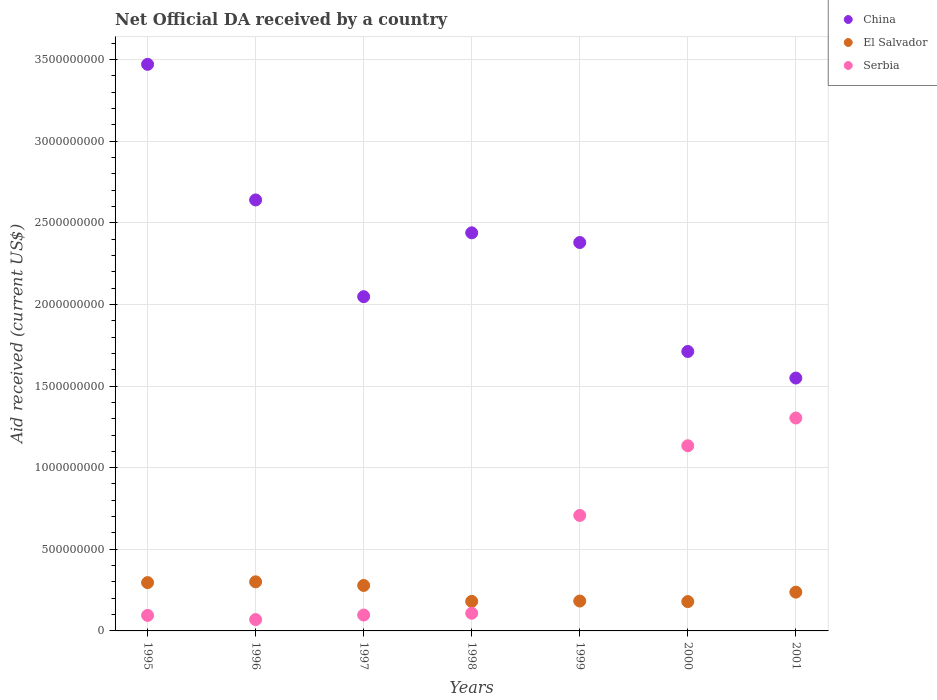How many different coloured dotlines are there?
Provide a succinct answer. 3. Is the number of dotlines equal to the number of legend labels?
Provide a short and direct response. Yes. What is the net official development assistance aid received in Serbia in 1999?
Provide a short and direct response. 7.07e+08. Across all years, what is the maximum net official development assistance aid received in China?
Make the answer very short. 3.47e+09. Across all years, what is the minimum net official development assistance aid received in El Salvador?
Make the answer very short. 1.80e+08. In which year was the net official development assistance aid received in China maximum?
Your response must be concise. 1995. What is the total net official development assistance aid received in China in the graph?
Provide a succinct answer. 1.62e+1. What is the difference between the net official development assistance aid received in China in 1996 and that in 1998?
Make the answer very short. 2.01e+08. What is the difference between the net official development assistance aid received in China in 1998 and the net official development assistance aid received in El Salvador in 1996?
Offer a very short reply. 2.14e+09. What is the average net official development assistance aid received in Serbia per year?
Offer a terse response. 5.02e+08. In the year 2001, what is the difference between the net official development assistance aid received in China and net official development assistance aid received in Serbia?
Offer a terse response. 2.45e+08. In how many years, is the net official development assistance aid received in El Salvador greater than 300000000 US$?
Your response must be concise. 1. What is the ratio of the net official development assistance aid received in El Salvador in 1998 to that in 1999?
Keep it short and to the point. 0.99. Is the net official development assistance aid received in Serbia in 1997 less than that in 1998?
Keep it short and to the point. Yes. What is the difference between the highest and the second highest net official development assistance aid received in Serbia?
Make the answer very short. 1.70e+08. What is the difference between the highest and the lowest net official development assistance aid received in China?
Offer a very short reply. 1.92e+09. In how many years, is the net official development assistance aid received in China greater than the average net official development assistance aid received in China taken over all years?
Ensure brevity in your answer.  4. Does the net official development assistance aid received in El Salvador monotonically increase over the years?
Your answer should be compact. No. Is the net official development assistance aid received in China strictly greater than the net official development assistance aid received in Serbia over the years?
Provide a short and direct response. Yes. What is the difference between two consecutive major ticks on the Y-axis?
Give a very brief answer. 5.00e+08. Does the graph contain grids?
Ensure brevity in your answer.  Yes. How many legend labels are there?
Make the answer very short. 3. How are the legend labels stacked?
Your answer should be very brief. Vertical. What is the title of the graph?
Offer a very short reply. Net Official DA received by a country. Does "Sint Maarten (Dutch part)" appear as one of the legend labels in the graph?
Give a very brief answer. No. What is the label or title of the X-axis?
Provide a succinct answer. Years. What is the label or title of the Y-axis?
Your answer should be compact. Aid received (current US$). What is the Aid received (current US$) of China in 1995?
Offer a very short reply. 3.47e+09. What is the Aid received (current US$) of El Salvador in 1995?
Your answer should be very brief. 2.96e+08. What is the Aid received (current US$) of Serbia in 1995?
Make the answer very short. 9.51e+07. What is the Aid received (current US$) of China in 1996?
Your response must be concise. 2.64e+09. What is the Aid received (current US$) in El Salvador in 1996?
Keep it short and to the point. 3.01e+08. What is the Aid received (current US$) of Serbia in 1996?
Offer a terse response. 6.95e+07. What is the Aid received (current US$) of China in 1997?
Provide a short and direct response. 2.05e+09. What is the Aid received (current US$) of El Salvador in 1997?
Keep it short and to the point. 2.79e+08. What is the Aid received (current US$) of Serbia in 1997?
Offer a very short reply. 9.74e+07. What is the Aid received (current US$) in China in 1998?
Keep it short and to the point. 2.44e+09. What is the Aid received (current US$) of El Salvador in 1998?
Your response must be concise. 1.81e+08. What is the Aid received (current US$) in Serbia in 1998?
Your answer should be very brief. 1.08e+08. What is the Aid received (current US$) of China in 1999?
Make the answer very short. 2.38e+09. What is the Aid received (current US$) in El Salvador in 1999?
Keep it short and to the point. 1.83e+08. What is the Aid received (current US$) in Serbia in 1999?
Make the answer very short. 7.07e+08. What is the Aid received (current US$) in China in 2000?
Your answer should be compact. 1.71e+09. What is the Aid received (current US$) of El Salvador in 2000?
Ensure brevity in your answer.  1.80e+08. What is the Aid received (current US$) in Serbia in 2000?
Ensure brevity in your answer.  1.13e+09. What is the Aid received (current US$) in China in 2001?
Your answer should be very brief. 1.55e+09. What is the Aid received (current US$) in El Salvador in 2001?
Your answer should be very brief. 2.38e+08. What is the Aid received (current US$) in Serbia in 2001?
Offer a terse response. 1.30e+09. Across all years, what is the maximum Aid received (current US$) in China?
Provide a short and direct response. 3.47e+09. Across all years, what is the maximum Aid received (current US$) of El Salvador?
Your answer should be very brief. 3.01e+08. Across all years, what is the maximum Aid received (current US$) in Serbia?
Give a very brief answer. 1.30e+09. Across all years, what is the minimum Aid received (current US$) of China?
Make the answer very short. 1.55e+09. Across all years, what is the minimum Aid received (current US$) of El Salvador?
Offer a very short reply. 1.80e+08. Across all years, what is the minimum Aid received (current US$) in Serbia?
Provide a succinct answer. 6.95e+07. What is the total Aid received (current US$) in China in the graph?
Provide a succinct answer. 1.62e+1. What is the total Aid received (current US$) in El Salvador in the graph?
Your response must be concise. 1.66e+09. What is the total Aid received (current US$) of Serbia in the graph?
Your answer should be very brief. 3.52e+09. What is the difference between the Aid received (current US$) of China in 1995 and that in 1996?
Your answer should be compact. 8.31e+08. What is the difference between the Aid received (current US$) in El Salvador in 1995 and that in 1996?
Offer a terse response. -4.81e+06. What is the difference between the Aid received (current US$) of Serbia in 1995 and that in 1996?
Make the answer very short. 2.56e+07. What is the difference between the Aid received (current US$) in China in 1995 and that in 1997?
Your answer should be compact. 1.42e+09. What is the difference between the Aid received (current US$) of El Salvador in 1995 and that in 1997?
Offer a terse response. 1.74e+07. What is the difference between the Aid received (current US$) of Serbia in 1995 and that in 1997?
Keep it short and to the point. -2.30e+06. What is the difference between the Aid received (current US$) in China in 1995 and that in 1998?
Ensure brevity in your answer.  1.03e+09. What is the difference between the Aid received (current US$) in El Salvador in 1995 and that in 1998?
Offer a terse response. 1.15e+08. What is the difference between the Aid received (current US$) of Serbia in 1995 and that in 1998?
Your response must be concise. -1.32e+07. What is the difference between the Aid received (current US$) in China in 1995 and that in 1999?
Provide a succinct answer. 1.09e+09. What is the difference between the Aid received (current US$) of El Salvador in 1995 and that in 1999?
Offer a terse response. 1.13e+08. What is the difference between the Aid received (current US$) in Serbia in 1995 and that in 1999?
Offer a very short reply. -6.12e+08. What is the difference between the Aid received (current US$) of China in 1995 and that in 2000?
Your answer should be very brief. 1.76e+09. What is the difference between the Aid received (current US$) in El Salvador in 1995 and that in 2000?
Give a very brief answer. 1.16e+08. What is the difference between the Aid received (current US$) in Serbia in 1995 and that in 2000?
Offer a very short reply. -1.04e+09. What is the difference between the Aid received (current US$) of China in 1995 and that in 2001?
Make the answer very short. 1.92e+09. What is the difference between the Aid received (current US$) of El Salvador in 1995 and that in 2001?
Give a very brief answer. 5.84e+07. What is the difference between the Aid received (current US$) of Serbia in 1995 and that in 2001?
Your response must be concise. -1.21e+09. What is the difference between the Aid received (current US$) in China in 1996 and that in 1997?
Your answer should be very brief. 5.93e+08. What is the difference between the Aid received (current US$) in El Salvador in 1996 and that in 1997?
Make the answer very short. 2.22e+07. What is the difference between the Aid received (current US$) in Serbia in 1996 and that in 1997?
Your response must be concise. -2.78e+07. What is the difference between the Aid received (current US$) in China in 1996 and that in 1998?
Offer a terse response. 2.01e+08. What is the difference between the Aid received (current US$) of El Salvador in 1996 and that in 1998?
Offer a very short reply. 1.20e+08. What is the difference between the Aid received (current US$) in Serbia in 1996 and that in 1998?
Keep it short and to the point. -3.87e+07. What is the difference between the Aid received (current US$) in China in 1996 and that in 1999?
Offer a very short reply. 2.61e+08. What is the difference between the Aid received (current US$) of El Salvador in 1996 and that in 1999?
Offer a terse response. 1.18e+08. What is the difference between the Aid received (current US$) in Serbia in 1996 and that in 1999?
Offer a very short reply. -6.38e+08. What is the difference between the Aid received (current US$) of China in 1996 and that in 2000?
Offer a terse response. 9.28e+08. What is the difference between the Aid received (current US$) of El Salvador in 1996 and that in 2000?
Provide a short and direct response. 1.21e+08. What is the difference between the Aid received (current US$) in Serbia in 1996 and that in 2000?
Ensure brevity in your answer.  -1.06e+09. What is the difference between the Aid received (current US$) of China in 1996 and that in 2001?
Provide a succinct answer. 1.09e+09. What is the difference between the Aid received (current US$) of El Salvador in 1996 and that in 2001?
Provide a short and direct response. 6.32e+07. What is the difference between the Aid received (current US$) in Serbia in 1996 and that in 2001?
Give a very brief answer. -1.23e+09. What is the difference between the Aid received (current US$) of China in 1997 and that in 1998?
Your response must be concise. -3.91e+08. What is the difference between the Aid received (current US$) in El Salvador in 1997 and that in 1998?
Your answer should be very brief. 9.76e+07. What is the difference between the Aid received (current US$) in Serbia in 1997 and that in 1998?
Keep it short and to the point. -1.09e+07. What is the difference between the Aid received (current US$) of China in 1997 and that in 1999?
Offer a very short reply. -3.32e+08. What is the difference between the Aid received (current US$) of El Salvador in 1997 and that in 1999?
Your answer should be compact. 9.54e+07. What is the difference between the Aid received (current US$) of Serbia in 1997 and that in 1999?
Offer a terse response. -6.10e+08. What is the difference between the Aid received (current US$) in China in 1997 and that in 2000?
Provide a succinct answer. 3.36e+08. What is the difference between the Aid received (current US$) in El Salvador in 1997 and that in 2000?
Keep it short and to the point. 9.89e+07. What is the difference between the Aid received (current US$) in Serbia in 1997 and that in 2000?
Your answer should be very brief. -1.04e+09. What is the difference between the Aid received (current US$) of China in 1997 and that in 2001?
Offer a very short reply. 4.98e+08. What is the difference between the Aid received (current US$) of El Salvador in 1997 and that in 2001?
Keep it short and to the point. 4.10e+07. What is the difference between the Aid received (current US$) in Serbia in 1997 and that in 2001?
Give a very brief answer. -1.21e+09. What is the difference between the Aid received (current US$) of China in 1998 and that in 1999?
Provide a succinct answer. 5.93e+07. What is the difference between the Aid received (current US$) of El Salvador in 1998 and that in 1999?
Provide a short and direct response. -2.15e+06. What is the difference between the Aid received (current US$) in Serbia in 1998 and that in 1999?
Give a very brief answer. -5.99e+08. What is the difference between the Aid received (current US$) of China in 1998 and that in 2000?
Your answer should be very brief. 7.27e+08. What is the difference between the Aid received (current US$) in El Salvador in 1998 and that in 2000?
Offer a very short reply. 1.28e+06. What is the difference between the Aid received (current US$) in Serbia in 1998 and that in 2000?
Provide a succinct answer. -1.03e+09. What is the difference between the Aid received (current US$) in China in 1998 and that in 2001?
Provide a short and direct response. 8.90e+08. What is the difference between the Aid received (current US$) in El Salvador in 1998 and that in 2001?
Ensure brevity in your answer.  -5.66e+07. What is the difference between the Aid received (current US$) in Serbia in 1998 and that in 2001?
Provide a short and direct response. -1.20e+09. What is the difference between the Aid received (current US$) in China in 1999 and that in 2000?
Give a very brief answer. 6.68e+08. What is the difference between the Aid received (current US$) in El Salvador in 1999 and that in 2000?
Keep it short and to the point. 3.43e+06. What is the difference between the Aid received (current US$) in Serbia in 1999 and that in 2000?
Make the answer very short. -4.27e+08. What is the difference between the Aid received (current US$) of China in 1999 and that in 2001?
Keep it short and to the point. 8.30e+08. What is the difference between the Aid received (current US$) of El Salvador in 1999 and that in 2001?
Give a very brief answer. -5.44e+07. What is the difference between the Aid received (current US$) in Serbia in 1999 and that in 2001?
Your response must be concise. -5.97e+08. What is the difference between the Aid received (current US$) of China in 2000 and that in 2001?
Make the answer very short. 1.63e+08. What is the difference between the Aid received (current US$) of El Salvador in 2000 and that in 2001?
Your response must be concise. -5.79e+07. What is the difference between the Aid received (current US$) of Serbia in 2000 and that in 2001?
Keep it short and to the point. -1.70e+08. What is the difference between the Aid received (current US$) of China in 1995 and the Aid received (current US$) of El Salvador in 1996?
Offer a very short reply. 3.17e+09. What is the difference between the Aid received (current US$) in China in 1995 and the Aid received (current US$) in Serbia in 1996?
Keep it short and to the point. 3.40e+09. What is the difference between the Aid received (current US$) in El Salvador in 1995 and the Aid received (current US$) in Serbia in 1996?
Your answer should be compact. 2.26e+08. What is the difference between the Aid received (current US$) of China in 1995 and the Aid received (current US$) of El Salvador in 1997?
Ensure brevity in your answer.  3.19e+09. What is the difference between the Aid received (current US$) in China in 1995 and the Aid received (current US$) in Serbia in 1997?
Your answer should be compact. 3.37e+09. What is the difference between the Aid received (current US$) of El Salvador in 1995 and the Aid received (current US$) of Serbia in 1997?
Your answer should be very brief. 1.99e+08. What is the difference between the Aid received (current US$) in China in 1995 and the Aid received (current US$) in El Salvador in 1998?
Your answer should be very brief. 3.29e+09. What is the difference between the Aid received (current US$) in China in 1995 and the Aid received (current US$) in Serbia in 1998?
Your response must be concise. 3.36e+09. What is the difference between the Aid received (current US$) of El Salvador in 1995 and the Aid received (current US$) of Serbia in 1998?
Give a very brief answer. 1.88e+08. What is the difference between the Aid received (current US$) in China in 1995 and the Aid received (current US$) in El Salvador in 1999?
Your answer should be compact. 3.29e+09. What is the difference between the Aid received (current US$) in China in 1995 and the Aid received (current US$) in Serbia in 1999?
Make the answer very short. 2.76e+09. What is the difference between the Aid received (current US$) in El Salvador in 1995 and the Aid received (current US$) in Serbia in 1999?
Your answer should be compact. -4.11e+08. What is the difference between the Aid received (current US$) in China in 1995 and the Aid received (current US$) in El Salvador in 2000?
Provide a short and direct response. 3.29e+09. What is the difference between the Aid received (current US$) of China in 1995 and the Aid received (current US$) of Serbia in 2000?
Make the answer very short. 2.34e+09. What is the difference between the Aid received (current US$) of El Salvador in 1995 and the Aid received (current US$) of Serbia in 2000?
Your response must be concise. -8.38e+08. What is the difference between the Aid received (current US$) of China in 1995 and the Aid received (current US$) of El Salvador in 2001?
Provide a short and direct response. 3.23e+09. What is the difference between the Aid received (current US$) in China in 1995 and the Aid received (current US$) in Serbia in 2001?
Give a very brief answer. 2.17e+09. What is the difference between the Aid received (current US$) of El Salvador in 1995 and the Aid received (current US$) of Serbia in 2001?
Ensure brevity in your answer.  -1.01e+09. What is the difference between the Aid received (current US$) of China in 1996 and the Aid received (current US$) of El Salvador in 1997?
Ensure brevity in your answer.  2.36e+09. What is the difference between the Aid received (current US$) in China in 1996 and the Aid received (current US$) in Serbia in 1997?
Make the answer very short. 2.54e+09. What is the difference between the Aid received (current US$) of El Salvador in 1996 and the Aid received (current US$) of Serbia in 1997?
Your response must be concise. 2.03e+08. What is the difference between the Aid received (current US$) in China in 1996 and the Aid received (current US$) in El Salvador in 1998?
Your response must be concise. 2.46e+09. What is the difference between the Aid received (current US$) in China in 1996 and the Aid received (current US$) in Serbia in 1998?
Keep it short and to the point. 2.53e+09. What is the difference between the Aid received (current US$) in El Salvador in 1996 and the Aid received (current US$) in Serbia in 1998?
Provide a short and direct response. 1.93e+08. What is the difference between the Aid received (current US$) of China in 1996 and the Aid received (current US$) of El Salvador in 1999?
Make the answer very short. 2.46e+09. What is the difference between the Aid received (current US$) of China in 1996 and the Aid received (current US$) of Serbia in 1999?
Provide a short and direct response. 1.93e+09. What is the difference between the Aid received (current US$) in El Salvador in 1996 and the Aid received (current US$) in Serbia in 1999?
Offer a terse response. -4.07e+08. What is the difference between the Aid received (current US$) in China in 1996 and the Aid received (current US$) in El Salvador in 2000?
Your answer should be very brief. 2.46e+09. What is the difference between the Aid received (current US$) in China in 1996 and the Aid received (current US$) in Serbia in 2000?
Offer a very short reply. 1.51e+09. What is the difference between the Aid received (current US$) in El Salvador in 1996 and the Aid received (current US$) in Serbia in 2000?
Provide a succinct answer. -8.34e+08. What is the difference between the Aid received (current US$) in China in 1996 and the Aid received (current US$) in El Salvador in 2001?
Your response must be concise. 2.40e+09. What is the difference between the Aid received (current US$) in China in 1996 and the Aid received (current US$) in Serbia in 2001?
Provide a succinct answer. 1.34e+09. What is the difference between the Aid received (current US$) in El Salvador in 1996 and the Aid received (current US$) in Serbia in 2001?
Provide a succinct answer. -1.00e+09. What is the difference between the Aid received (current US$) of China in 1997 and the Aid received (current US$) of El Salvador in 1998?
Provide a short and direct response. 1.87e+09. What is the difference between the Aid received (current US$) of China in 1997 and the Aid received (current US$) of Serbia in 1998?
Offer a very short reply. 1.94e+09. What is the difference between the Aid received (current US$) in El Salvador in 1997 and the Aid received (current US$) in Serbia in 1998?
Offer a terse response. 1.70e+08. What is the difference between the Aid received (current US$) of China in 1997 and the Aid received (current US$) of El Salvador in 1999?
Make the answer very short. 1.86e+09. What is the difference between the Aid received (current US$) of China in 1997 and the Aid received (current US$) of Serbia in 1999?
Provide a short and direct response. 1.34e+09. What is the difference between the Aid received (current US$) of El Salvador in 1997 and the Aid received (current US$) of Serbia in 1999?
Provide a short and direct response. -4.29e+08. What is the difference between the Aid received (current US$) of China in 1997 and the Aid received (current US$) of El Salvador in 2000?
Provide a succinct answer. 1.87e+09. What is the difference between the Aid received (current US$) in China in 1997 and the Aid received (current US$) in Serbia in 2000?
Provide a succinct answer. 9.13e+08. What is the difference between the Aid received (current US$) of El Salvador in 1997 and the Aid received (current US$) of Serbia in 2000?
Your response must be concise. -8.56e+08. What is the difference between the Aid received (current US$) in China in 1997 and the Aid received (current US$) in El Salvador in 2001?
Give a very brief answer. 1.81e+09. What is the difference between the Aid received (current US$) in China in 1997 and the Aid received (current US$) in Serbia in 2001?
Make the answer very short. 7.43e+08. What is the difference between the Aid received (current US$) in El Salvador in 1997 and the Aid received (current US$) in Serbia in 2001?
Offer a terse response. -1.03e+09. What is the difference between the Aid received (current US$) in China in 1998 and the Aid received (current US$) in El Salvador in 1999?
Provide a succinct answer. 2.26e+09. What is the difference between the Aid received (current US$) in China in 1998 and the Aid received (current US$) in Serbia in 1999?
Your response must be concise. 1.73e+09. What is the difference between the Aid received (current US$) of El Salvador in 1998 and the Aid received (current US$) of Serbia in 1999?
Provide a short and direct response. -5.26e+08. What is the difference between the Aid received (current US$) in China in 1998 and the Aid received (current US$) in El Salvador in 2000?
Your answer should be compact. 2.26e+09. What is the difference between the Aid received (current US$) of China in 1998 and the Aid received (current US$) of Serbia in 2000?
Ensure brevity in your answer.  1.30e+09. What is the difference between the Aid received (current US$) of El Salvador in 1998 and the Aid received (current US$) of Serbia in 2000?
Your answer should be very brief. -9.53e+08. What is the difference between the Aid received (current US$) in China in 1998 and the Aid received (current US$) in El Salvador in 2001?
Your answer should be very brief. 2.20e+09. What is the difference between the Aid received (current US$) in China in 1998 and the Aid received (current US$) in Serbia in 2001?
Offer a terse response. 1.13e+09. What is the difference between the Aid received (current US$) in El Salvador in 1998 and the Aid received (current US$) in Serbia in 2001?
Ensure brevity in your answer.  -1.12e+09. What is the difference between the Aid received (current US$) of China in 1999 and the Aid received (current US$) of El Salvador in 2000?
Ensure brevity in your answer.  2.20e+09. What is the difference between the Aid received (current US$) of China in 1999 and the Aid received (current US$) of Serbia in 2000?
Your answer should be compact. 1.24e+09. What is the difference between the Aid received (current US$) of El Salvador in 1999 and the Aid received (current US$) of Serbia in 2000?
Provide a short and direct response. -9.51e+08. What is the difference between the Aid received (current US$) of China in 1999 and the Aid received (current US$) of El Salvador in 2001?
Give a very brief answer. 2.14e+09. What is the difference between the Aid received (current US$) in China in 1999 and the Aid received (current US$) in Serbia in 2001?
Offer a very short reply. 1.08e+09. What is the difference between the Aid received (current US$) in El Salvador in 1999 and the Aid received (current US$) in Serbia in 2001?
Keep it short and to the point. -1.12e+09. What is the difference between the Aid received (current US$) of China in 2000 and the Aid received (current US$) of El Salvador in 2001?
Your response must be concise. 1.47e+09. What is the difference between the Aid received (current US$) of China in 2000 and the Aid received (current US$) of Serbia in 2001?
Your answer should be very brief. 4.08e+08. What is the difference between the Aid received (current US$) of El Salvador in 2000 and the Aid received (current US$) of Serbia in 2001?
Give a very brief answer. -1.12e+09. What is the average Aid received (current US$) in China per year?
Your answer should be compact. 2.32e+09. What is the average Aid received (current US$) in El Salvador per year?
Give a very brief answer. 2.37e+08. What is the average Aid received (current US$) in Serbia per year?
Provide a succinct answer. 5.02e+08. In the year 1995, what is the difference between the Aid received (current US$) in China and Aid received (current US$) in El Salvador?
Provide a short and direct response. 3.17e+09. In the year 1995, what is the difference between the Aid received (current US$) in China and Aid received (current US$) in Serbia?
Ensure brevity in your answer.  3.38e+09. In the year 1995, what is the difference between the Aid received (current US$) of El Salvador and Aid received (current US$) of Serbia?
Make the answer very short. 2.01e+08. In the year 1996, what is the difference between the Aid received (current US$) of China and Aid received (current US$) of El Salvador?
Ensure brevity in your answer.  2.34e+09. In the year 1996, what is the difference between the Aid received (current US$) in China and Aid received (current US$) in Serbia?
Offer a terse response. 2.57e+09. In the year 1996, what is the difference between the Aid received (current US$) of El Salvador and Aid received (current US$) of Serbia?
Give a very brief answer. 2.31e+08. In the year 1997, what is the difference between the Aid received (current US$) in China and Aid received (current US$) in El Salvador?
Provide a short and direct response. 1.77e+09. In the year 1997, what is the difference between the Aid received (current US$) in China and Aid received (current US$) in Serbia?
Offer a terse response. 1.95e+09. In the year 1997, what is the difference between the Aid received (current US$) of El Salvador and Aid received (current US$) of Serbia?
Ensure brevity in your answer.  1.81e+08. In the year 1998, what is the difference between the Aid received (current US$) of China and Aid received (current US$) of El Salvador?
Ensure brevity in your answer.  2.26e+09. In the year 1998, what is the difference between the Aid received (current US$) of China and Aid received (current US$) of Serbia?
Give a very brief answer. 2.33e+09. In the year 1998, what is the difference between the Aid received (current US$) in El Salvador and Aid received (current US$) in Serbia?
Offer a terse response. 7.27e+07. In the year 1999, what is the difference between the Aid received (current US$) of China and Aid received (current US$) of El Salvador?
Offer a terse response. 2.20e+09. In the year 1999, what is the difference between the Aid received (current US$) of China and Aid received (current US$) of Serbia?
Your answer should be very brief. 1.67e+09. In the year 1999, what is the difference between the Aid received (current US$) in El Salvador and Aid received (current US$) in Serbia?
Your answer should be compact. -5.24e+08. In the year 2000, what is the difference between the Aid received (current US$) of China and Aid received (current US$) of El Salvador?
Your answer should be very brief. 1.53e+09. In the year 2000, what is the difference between the Aid received (current US$) of China and Aid received (current US$) of Serbia?
Offer a very short reply. 5.77e+08. In the year 2000, what is the difference between the Aid received (current US$) in El Salvador and Aid received (current US$) in Serbia?
Provide a succinct answer. -9.55e+08. In the year 2001, what is the difference between the Aid received (current US$) of China and Aid received (current US$) of El Salvador?
Your response must be concise. 1.31e+09. In the year 2001, what is the difference between the Aid received (current US$) of China and Aid received (current US$) of Serbia?
Offer a terse response. 2.45e+08. In the year 2001, what is the difference between the Aid received (current US$) of El Salvador and Aid received (current US$) of Serbia?
Your answer should be compact. -1.07e+09. What is the ratio of the Aid received (current US$) in China in 1995 to that in 1996?
Your response must be concise. 1.31. What is the ratio of the Aid received (current US$) of El Salvador in 1995 to that in 1996?
Your answer should be compact. 0.98. What is the ratio of the Aid received (current US$) of Serbia in 1995 to that in 1996?
Your answer should be very brief. 1.37. What is the ratio of the Aid received (current US$) of China in 1995 to that in 1997?
Ensure brevity in your answer.  1.7. What is the ratio of the Aid received (current US$) in El Salvador in 1995 to that in 1997?
Provide a succinct answer. 1.06. What is the ratio of the Aid received (current US$) in Serbia in 1995 to that in 1997?
Ensure brevity in your answer.  0.98. What is the ratio of the Aid received (current US$) of China in 1995 to that in 1998?
Offer a very short reply. 1.42. What is the ratio of the Aid received (current US$) in El Salvador in 1995 to that in 1998?
Give a very brief answer. 1.64. What is the ratio of the Aid received (current US$) of Serbia in 1995 to that in 1998?
Give a very brief answer. 0.88. What is the ratio of the Aid received (current US$) of China in 1995 to that in 1999?
Your response must be concise. 1.46. What is the ratio of the Aid received (current US$) in El Salvador in 1995 to that in 1999?
Ensure brevity in your answer.  1.62. What is the ratio of the Aid received (current US$) in Serbia in 1995 to that in 1999?
Your answer should be very brief. 0.13. What is the ratio of the Aid received (current US$) in China in 1995 to that in 2000?
Your answer should be compact. 2.03. What is the ratio of the Aid received (current US$) in El Salvador in 1995 to that in 2000?
Give a very brief answer. 1.65. What is the ratio of the Aid received (current US$) of Serbia in 1995 to that in 2000?
Ensure brevity in your answer.  0.08. What is the ratio of the Aid received (current US$) in China in 1995 to that in 2001?
Your answer should be very brief. 2.24. What is the ratio of the Aid received (current US$) of El Salvador in 1995 to that in 2001?
Keep it short and to the point. 1.25. What is the ratio of the Aid received (current US$) in Serbia in 1995 to that in 2001?
Make the answer very short. 0.07. What is the ratio of the Aid received (current US$) of China in 1996 to that in 1997?
Ensure brevity in your answer.  1.29. What is the ratio of the Aid received (current US$) of El Salvador in 1996 to that in 1997?
Your answer should be very brief. 1.08. What is the ratio of the Aid received (current US$) in Serbia in 1996 to that in 1997?
Offer a terse response. 0.71. What is the ratio of the Aid received (current US$) of China in 1996 to that in 1998?
Offer a very short reply. 1.08. What is the ratio of the Aid received (current US$) in El Salvador in 1996 to that in 1998?
Offer a terse response. 1.66. What is the ratio of the Aid received (current US$) of Serbia in 1996 to that in 1998?
Make the answer very short. 0.64. What is the ratio of the Aid received (current US$) of China in 1996 to that in 1999?
Offer a terse response. 1.11. What is the ratio of the Aid received (current US$) of El Salvador in 1996 to that in 1999?
Offer a terse response. 1.64. What is the ratio of the Aid received (current US$) of Serbia in 1996 to that in 1999?
Your answer should be compact. 0.1. What is the ratio of the Aid received (current US$) in China in 1996 to that in 2000?
Your answer should be compact. 1.54. What is the ratio of the Aid received (current US$) of El Salvador in 1996 to that in 2000?
Make the answer very short. 1.67. What is the ratio of the Aid received (current US$) in Serbia in 1996 to that in 2000?
Keep it short and to the point. 0.06. What is the ratio of the Aid received (current US$) in China in 1996 to that in 2001?
Your response must be concise. 1.7. What is the ratio of the Aid received (current US$) of El Salvador in 1996 to that in 2001?
Give a very brief answer. 1.27. What is the ratio of the Aid received (current US$) in Serbia in 1996 to that in 2001?
Ensure brevity in your answer.  0.05. What is the ratio of the Aid received (current US$) of China in 1997 to that in 1998?
Keep it short and to the point. 0.84. What is the ratio of the Aid received (current US$) in El Salvador in 1997 to that in 1998?
Offer a terse response. 1.54. What is the ratio of the Aid received (current US$) in Serbia in 1997 to that in 1998?
Ensure brevity in your answer.  0.9. What is the ratio of the Aid received (current US$) of China in 1997 to that in 1999?
Give a very brief answer. 0.86. What is the ratio of the Aid received (current US$) in El Salvador in 1997 to that in 1999?
Keep it short and to the point. 1.52. What is the ratio of the Aid received (current US$) in Serbia in 1997 to that in 1999?
Make the answer very short. 0.14. What is the ratio of the Aid received (current US$) of China in 1997 to that in 2000?
Make the answer very short. 1.2. What is the ratio of the Aid received (current US$) in El Salvador in 1997 to that in 2000?
Give a very brief answer. 1.55. What is the ratio of the Aid received (current US$) of Serbia in 1997 to that in 2000?
Make the answer very short. 0.09. What is the ratio of the Aid received (current US$) in China in 1997 to that in 2001?
Your answer should be compact. 1.32. What is the ratio of the Aid received (current US$) of El Salvador in 1997 to that in 2001?
Provide a succinct answer. 1.17. What is the ratio of the Aid received (current US$) of Serbia in 1997 to that in 2001?
Ensure brevity in your answer.  0.07. What is the ratio of the Aid received (current US$) in China in 1998 to that in 1999?
Offer a very short reply. 1.02. What is the ratio of the Aid received (current US$) in El Salvador in 1998 to that in 1999?
Give a very brief answer. 0.99. What is the ratio of the Aid received (current US$) in Serbia in 1998 to that in 1999?
Offer a very short reply. 0.15. What is the ratio of the Aid received (current US$) in China in 1998 to that in 2000?
Your answer should be very brief. 1.42. What is the ratio of the Aid received (current US$) in El Salvador in 1998 to that in 2000?
Offer a very short reply. 1.01. What is the ratio of the Aid received (current US$) in Serbia in 1998 to that in 2000?
Offer a very short reply. 0.1. What is the ratio of the Aid received (current US$) of China in 1998 to that in 2001?
Your answer should be compact. 1.57. What is the ratio of the Aid received (current US$) in El Salvador in 1998 to that in 2001?
Ensure brevity in your answer.  0.76. What is the ratio of the Aid received (current US$) in Serbia in 1998 to that in 2001?
Give a very brief answer. 0.08. What is the ratio of the Aid received (current US$) of China in 1999 to that in 2000?
Your answer should be very brief. 1.39. What is the ratio of the Aid received (current US$) in El Salvador in 1999 to that in 2000?
Keep it short and to the point. 1.02. What is the ratio of the Aid received (current US$) of Serbia in 1999 to that in 2000?
Your answer should be very brief. 0.62. What is the ratio of the Aid received (current US$) of China in 1999 to that in 2001?
Make the answer very short. 1.54. What is the ratio of the Aid received (current US$) in El Salvador in 1999 to that in 2001?
Offer a very short reply. 0.77. What is the ratio of the Aid received (current US$) of Serbia in 1999 to that in 2001?
Your answer should be compact. 0.54. What is the ratio of the Aid received (current US$) of China in 2000 to that in 2001?
Your answer should be very brief. 1.1. What is the ratio of the Aid received (current US$) in El Salvador in 2000 to that in 2001?
Give a very brief answer. 0.76. What is the ratio of the Aid received (current US$) of Serbia in 2000 to that in 2001?
Make the answer very short. 0.87. What is the difference between the highest and the second highest Aid received (current US$) of China?
Make the answer very short. 8.31e+08. What is the difference between the highest and the second highest Aid received (current US$) of El Salvador?
Keep it short and to the point. 4.81e+06. What is the difference between the highest and the second highest Aid received (current US$) of Serbia?
Ensure brevity in your answer.  1.70e+08. What is the difference between the highest and the lowest Aid received (current US$) of China?
Provide a short and direct response. 1.92e+09. What is the difference between the highest and the lowest Aid received (current US$) in El Salvador?
Provide a succinct answer. 1.21e+08. What is the difference between the highest and the lowest Aid received (current US$) in Serbia?
Your response must be concise. 1.23e+09. 